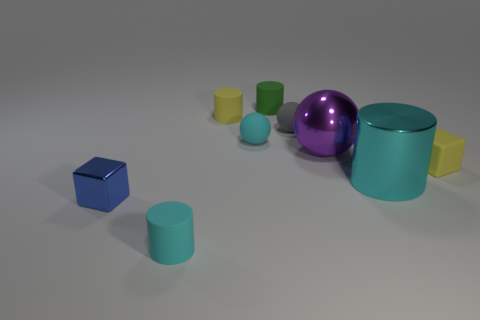Add 1 large purple shiny cylinders. How many objects exist? 10 Subtract all cubes. How many objects are left? 7 Subtract 0 red cylinders. How many objects are left? 9 Subtract all small green matte cylinders. Subtract all small cyan rubber objects. How many objects are left? 6 Add 8 small cyan matte things. How many small cyan matte things are left? 10 Add 8 cyan spheres. How many cyan spheres exist? 9 